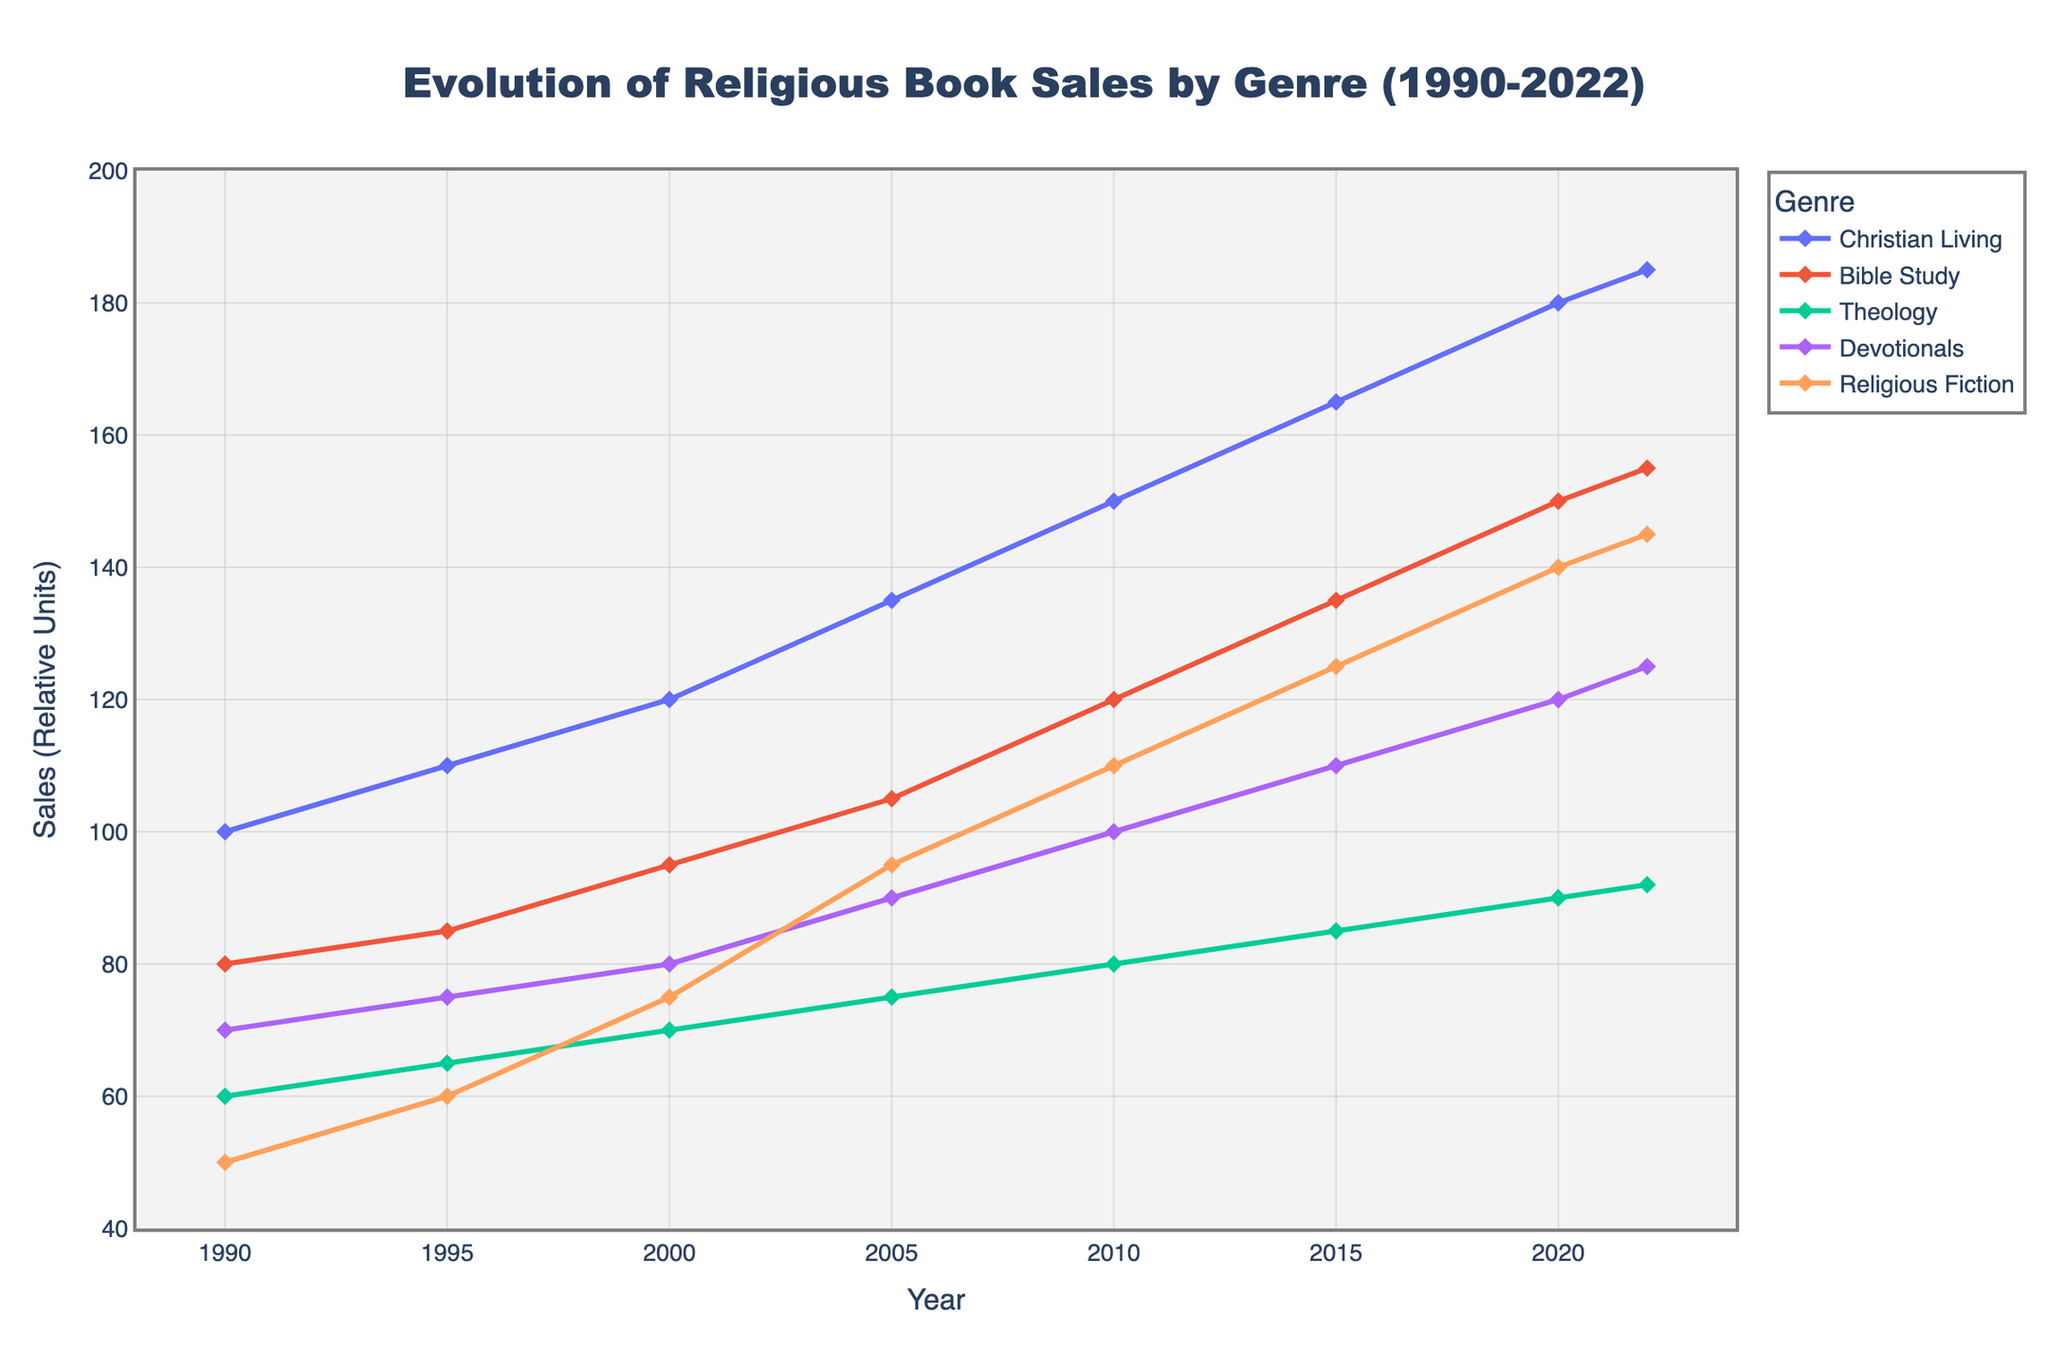What's the trend for the genre 'Christian Living' from 1990 to 2022? The line representing 'Christian Living' starts at 100 in 1990 and rises consistently over the years, reaching 185 in 2022.
Answer: Upward trend Between 2010 and 2015, which genre saw the largest increase in sales? By subtracting 2010 sales from 2015 sales for each genre: Christian Living (165-150=15), Bible Study (135-120=15), Theology (85-80=5), Devotionals (110-100=10), Religious Fiction (125-110=15), we see that Christian Living, Bible Study, and Religious Fiction each saw the largest increase of 15 units.
Answer: Christian Living, Bible Study, Religious Fiction (tied) How do the sales of 'Bible Study' in 2020 compare to 'Theology' in 2005? In 2020, the sales of 'Bible Study' are 150 units, while in 2005, the sales of 'Theology' are 75 units. 150 is greater than 75.
Answer: Bible Study in 2020 is greater What is the average sales increase per year for 'Devotionals' from 1990 to 2022? 'Devotionals' sales increase is from 70 in 1990 to 125 in 2022. The total increase is 125-70=55 over 32 years. The average increase per year is 55/32 ≈ 1.72 units.
Answer: Approximately 1.72 units per year Which genre had the second highest sales in 2000? By looking at the values for 2000: Christian Living (120), Bible Study (95), Theology (70), Devotionals (80), Religious Fiction (75), Bible Study with 95 units is the second highest.
Answer: Bible Study What was the percentage increase in sales for 'Religious Fiction' from 1990 to 2022? Sales for 'Religious Fiction' go from 50 in 1990 to 145 in 2022. The increase is 145-50=95 units. The percentage increase is (95/50) * 100 = 190%.
Answer: 190% What is the combined total sales for all genres in the year 2005? Summing up the 2005 values: Christian Living (135), Bible Study (105), Theology (75), Devotionals (90), Religious Fiction (95), the total is 135+105+75+90+95=500 units.
Answer: 500 units How do the trends of 'Theology' and 'Devotionals' compare from 1990 to 2022? 'Theology' shows a steady increase from 60 in 1990 to 92 in 2022, while 'Devotionals' also shows an upward trend but starts from 70 in 1990 and rises to 125 in 2022. Devotionals consistently stay ahead of Theology in sales, with a larger overall increase.
Answer: Both are upward, but Devotionals rises more and stays ahead 